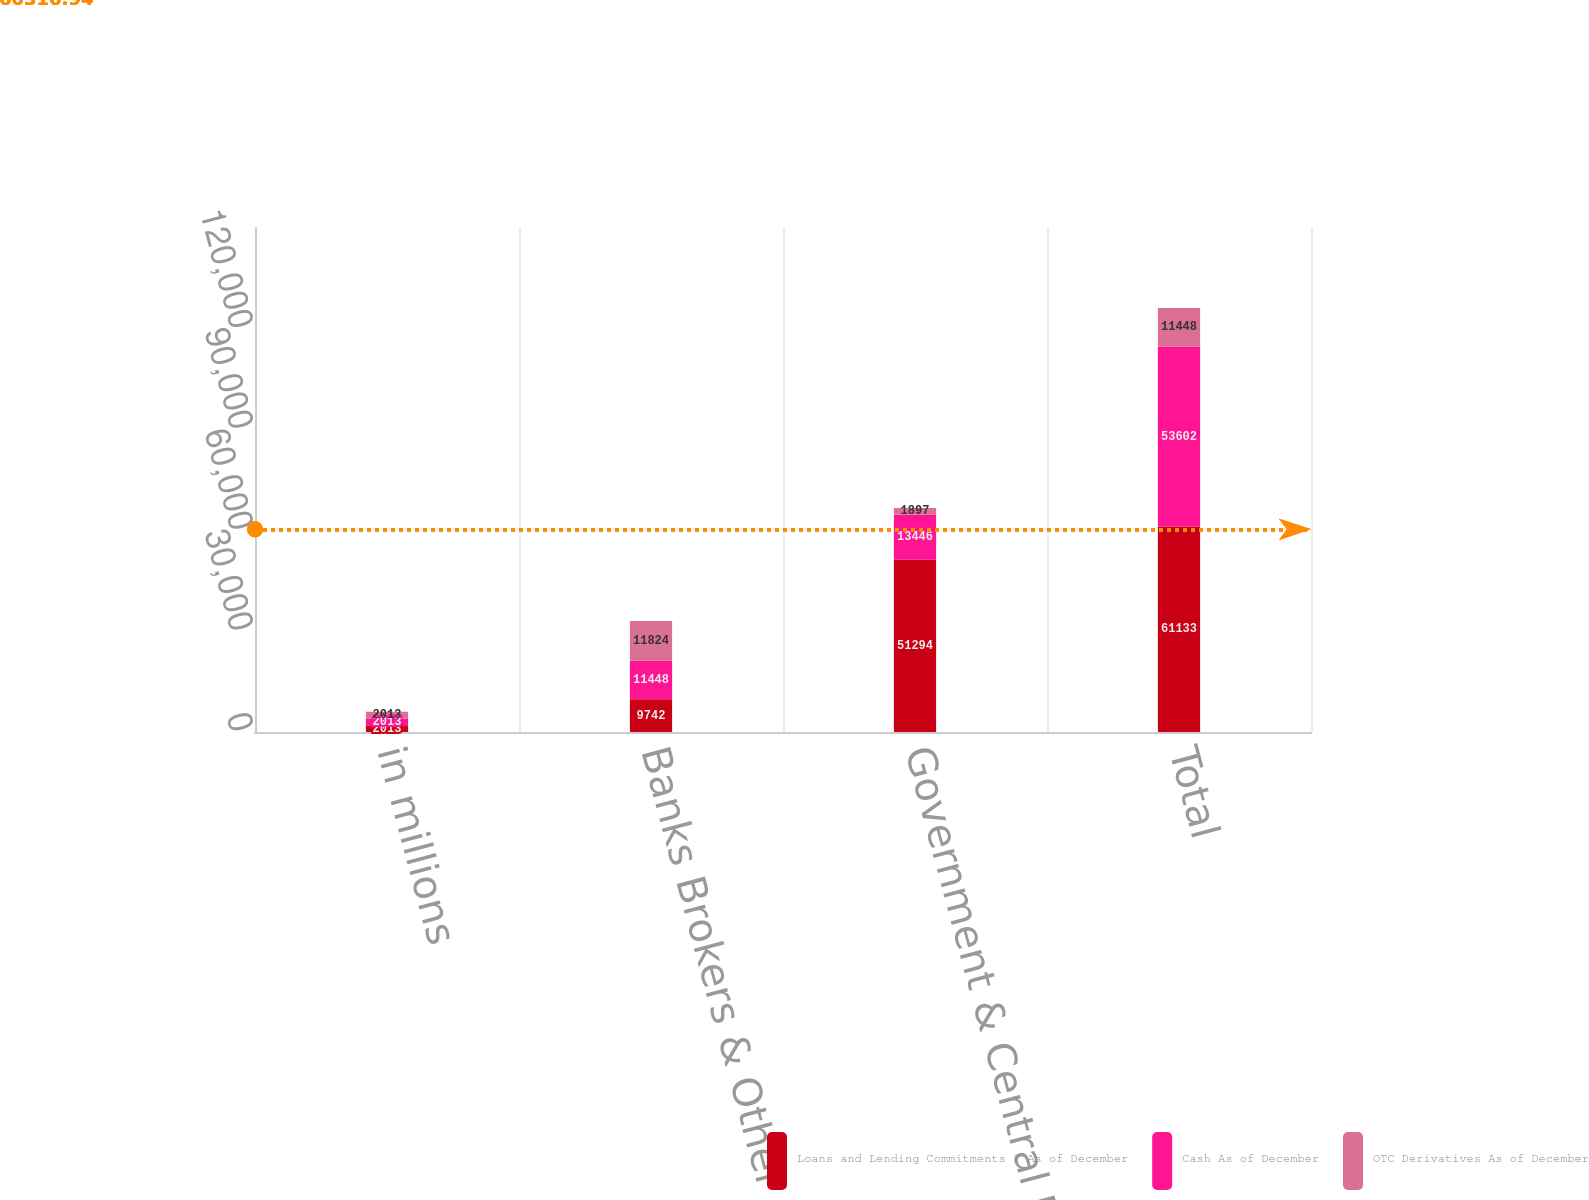<chart> <loc_0><loc_0><loc_500><loc_500><stacked_bar_chart><ecel><fcel>in millions<fcel>Banks Brokers & Other<fcel>Government & Central Banks<fcel>Total<nl><fcel>Loans and Lending Commitments 1 As of December<fcel>2013<fcel>9742<fcel>51294<fcel>61133<nl><fcel>Cash As of December<fcel>2013<fcel>11448<fcel>13446<fcel>53602<nl><fcel>OTC Derivatives As of December<fcel>2013<fcel>11824<fcel>1897<fcel>11448<nl></chart> 